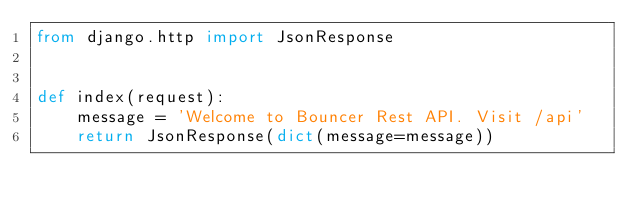<code> <loc_0><loc_0><loc_500><loc_500><_Python_>from django.http import JsonResponse


def index(request):
    message = 'Welcome to Bouncer Rest API. Visit /api'
    return JsonResponse(dict(message=message))
</code> 